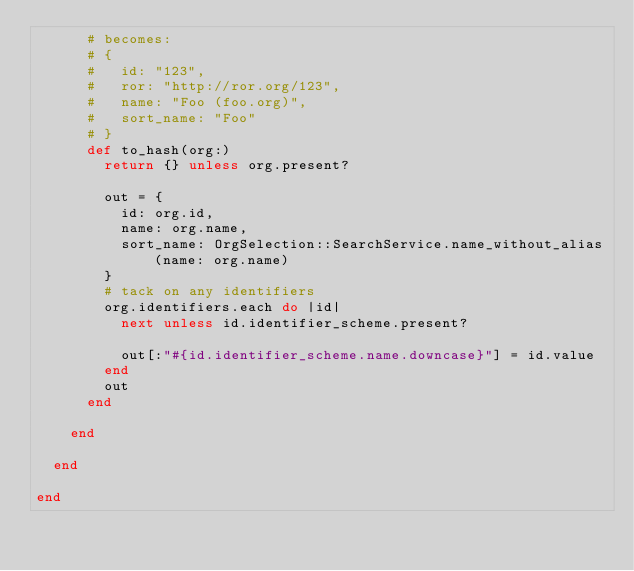Convert code to text. <code><loc_0><loc_0><loc_500><loc_500><_Ruby_>      # becomes:
      # {
      #   id: "123",
      #   ror: "http://ror.org/123",
      #   name: "Foo (foo.org)",
      #   sort_name: "Foo"
      # }
      def to_hash(org:)
        return {} unless org.present?

        out = {
          id: org.id,
          name: org.name,
          sort_name: OrgSelection::SearchService.name_without_alias(name: org.name)
        }
        # tack on any identifiers
        org.identifiers.each do |id|
          next unless id.identifier_scheme.present?

          out[:"#{id.identifier_scheme.name.downcase}"] = id.value
        end
        out
      end

    end

  end

end
</code> 